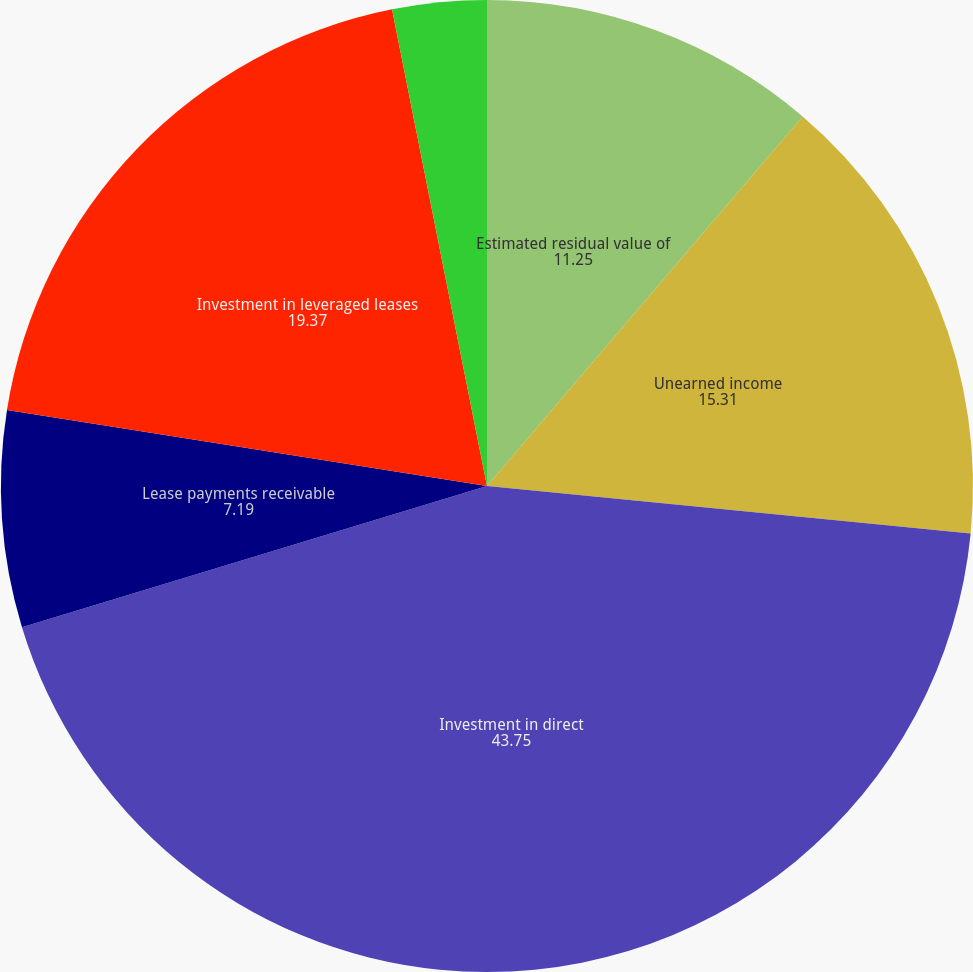Convert chart to OTSL. <chart><loc_0><loc_0><loc_500><loc_500><pie_chart><fcel>Estimated residual value of<fcel>Unearned income<fcel>Investment in direct<fcel>Lease payments receivable<fcel>Investment in leveraged leases<fcel>Deferred taxes payable arising<nl><fcel>11.25%<fcel>15.31%<fcel>43.75%<fcel>7.19%<fcel>19.37%<fcel>3.13%<nl></chart> 